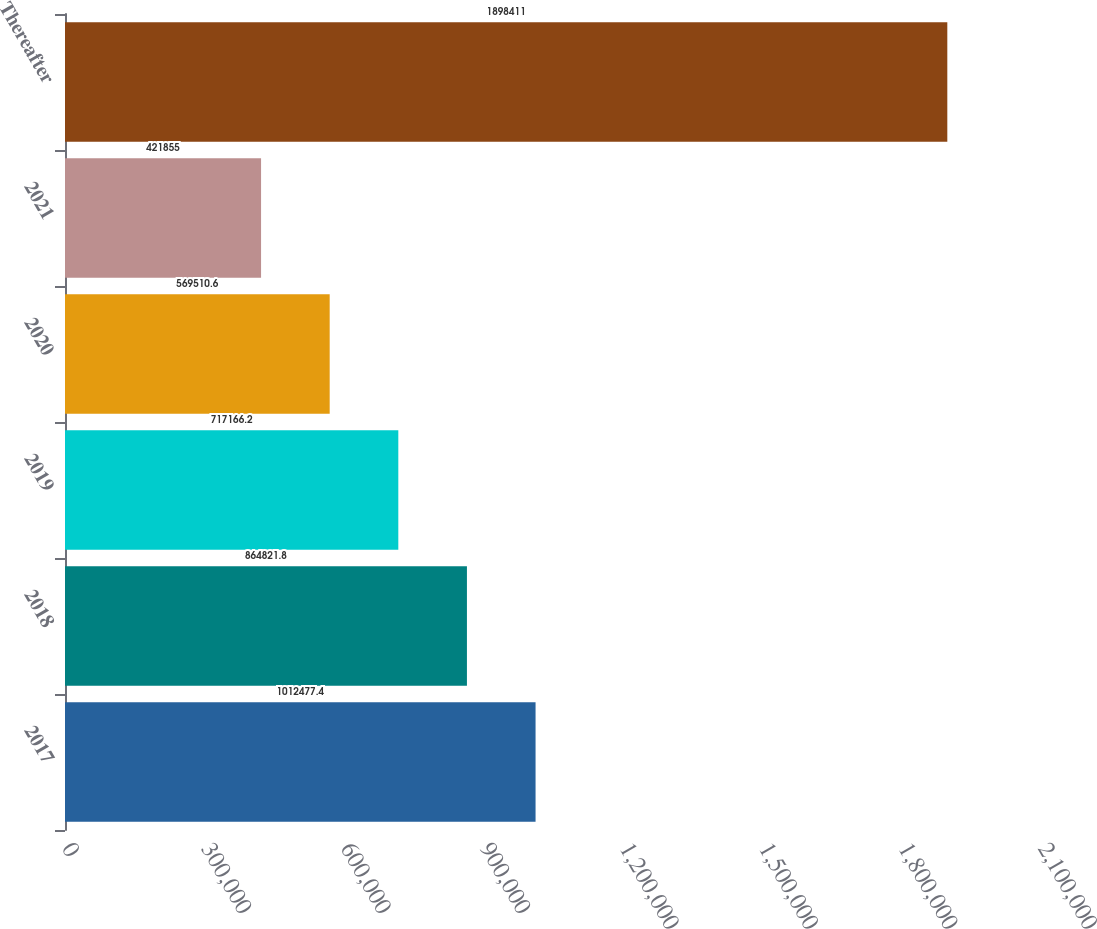<chart> <loc_0><loc_0><loc_500><loc_500><bar_chart><fcel>2017<fcel>2018<fcel>2019<fcel>2020<fcel>2021<fcel>Thereafter<nl><fcel>1.01248e+06<fcel>864822<fcel>717166<fcel>569511<fcel>421855<fcel>1.89841e+06<nl></chart> 